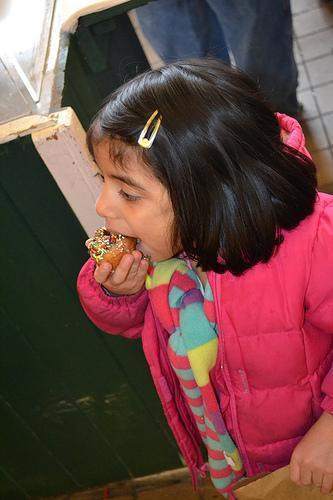How many children are in this photograph?
Give a very brief answer. 1. 